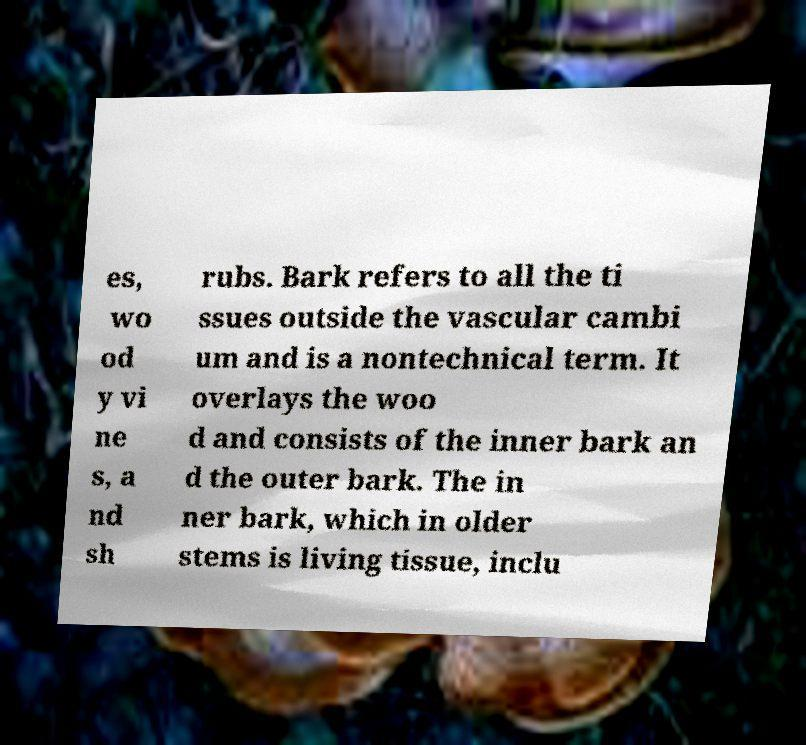Can you accurately transcribe the text from the provided image for me? es, wo od y vi ne s, a nd sh rubs. Bark refers to all the ti ssues outside the vascular cambi um and is a nontechnical term. It overlays the woo d and consists of the inner bark an d the outer bark. The in ner bark, which in older stems is living tissue, inclu 